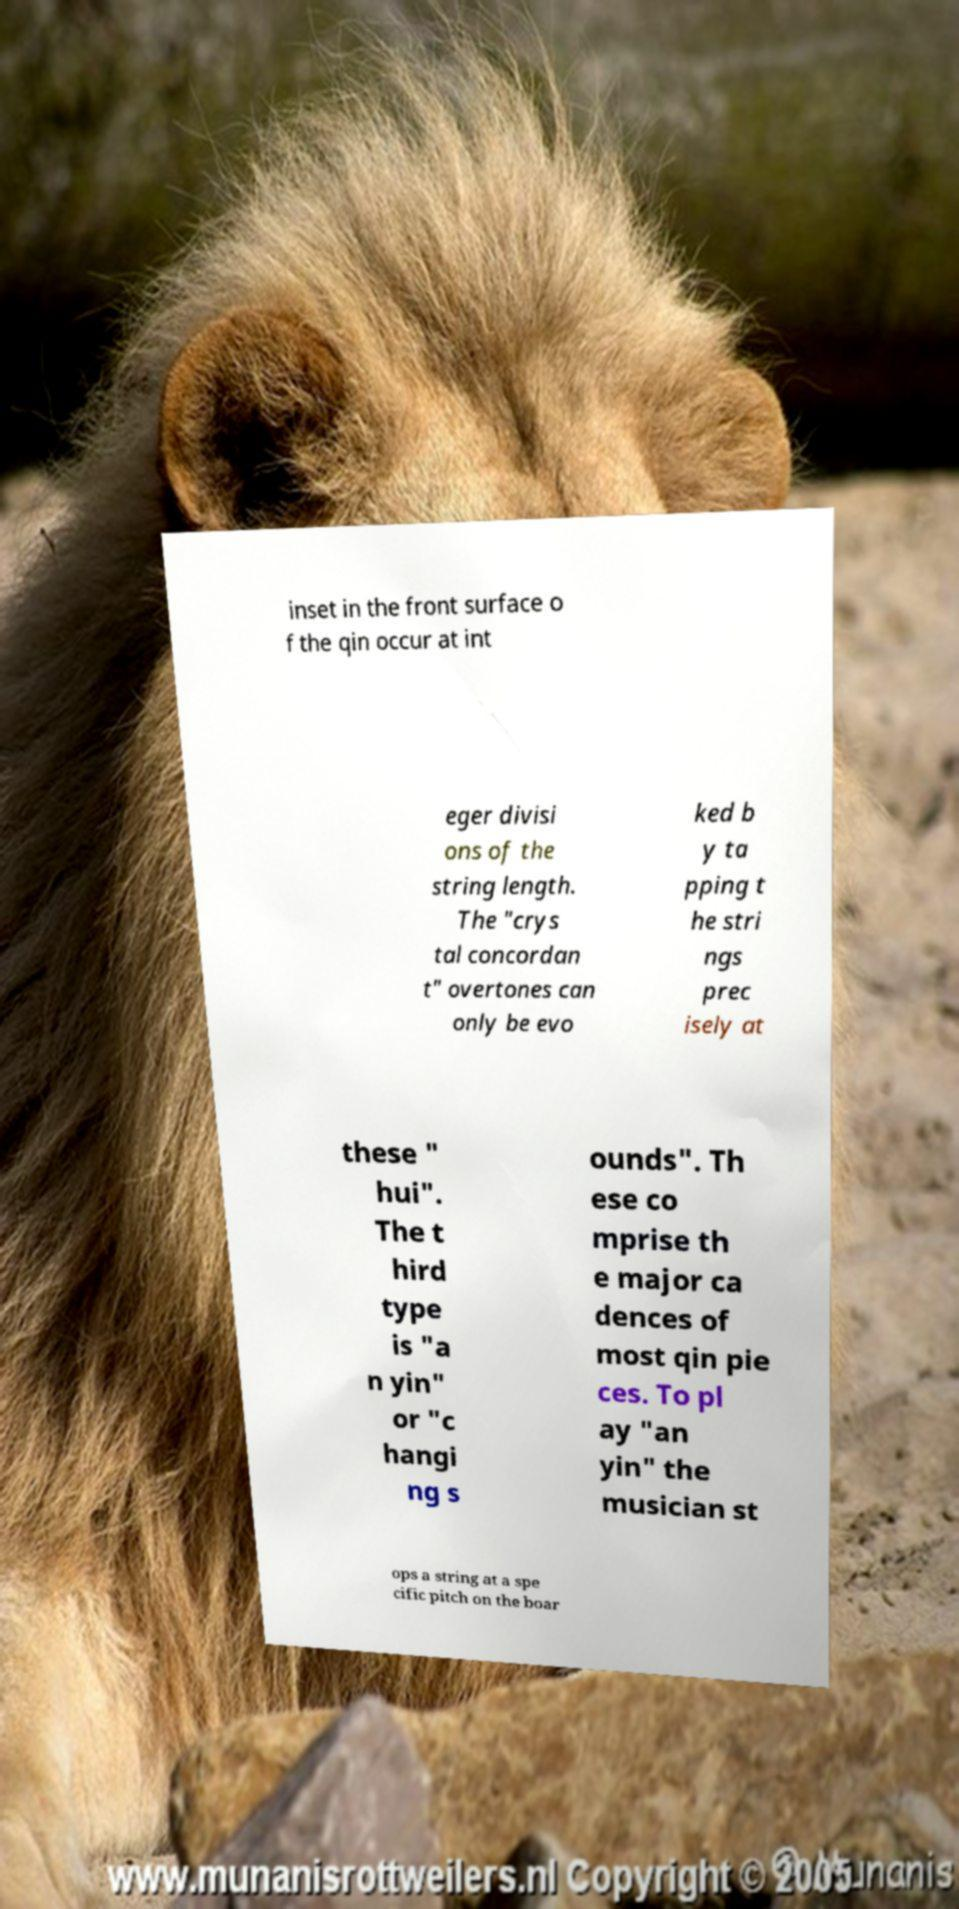Could you assist in decoding the text presented in this image and type it out clearly? inset in the front surface o f the qin occur at int eger divisi ons of the string length. The "crys tal concordan t" overtones can only be evo ked b y ta pping t he stri ngs prec isely at these " hui". The t hird type is "a n yin" or "c hangi ng s ounds". Th ese co mprise th e major ca dences of most qin pie ces. To pl ay "an yin" the musician st ops a string at a spe cific pitch on the boar 